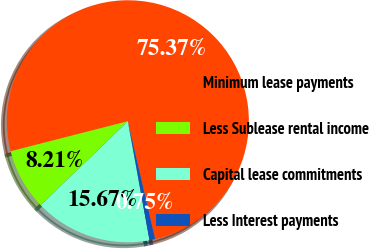<chart> <loc_0><loc_0><loc_500><loc_500><pie_chart><fcel>Minimum lease payments<fcel>Less Sublease rental income<fcel>Capital lease commitments<fcel>Less Interest payments<nl><fcel>75.37%<fcel>8.21%<fcel>15.67%<fcel>0.75%<nl></chart> 